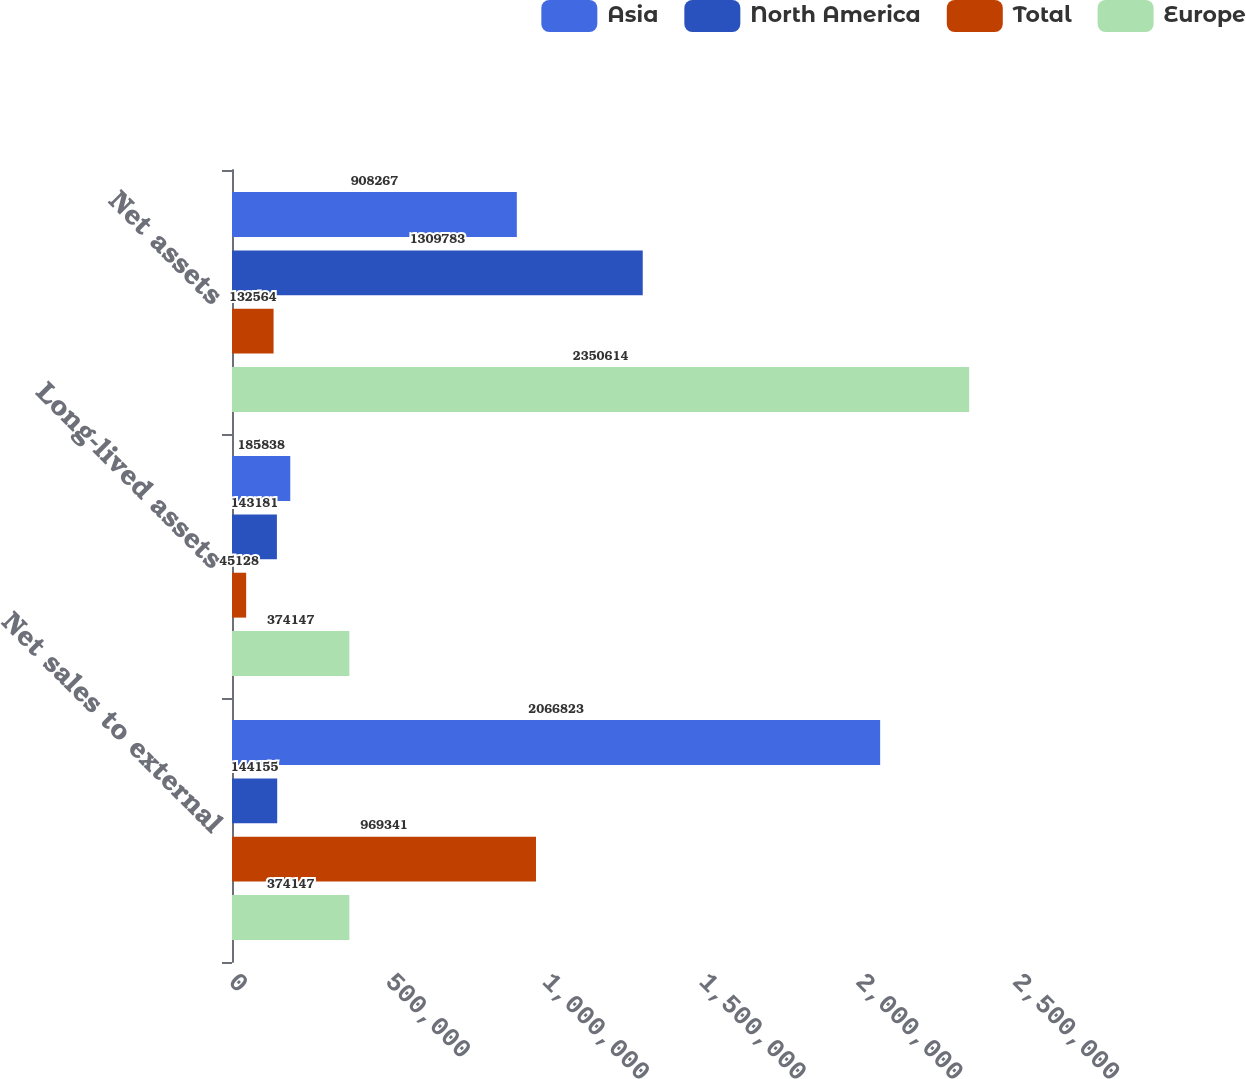Convert chart. <chart><loc_0><loc_0><loc_500><loc_500><stacked_bar_chart><ecel><fcel>Net sales to external<fcel>Long-lived assets<fcel>Net assets<nl><fcel>Asia<fcel>2.06682e+06<fcel>185838<fcel>908267<nl><fcel>North America<fcel>144155<fcel>143181<fcel>1.30978e+06<nl><fcel>Total<fcel>969341<fcel>45128<fcel>132564<nl><fcel>Europe<fcel>374147<fcel>374147<fcel>2.35061e+06<nl></chart> 